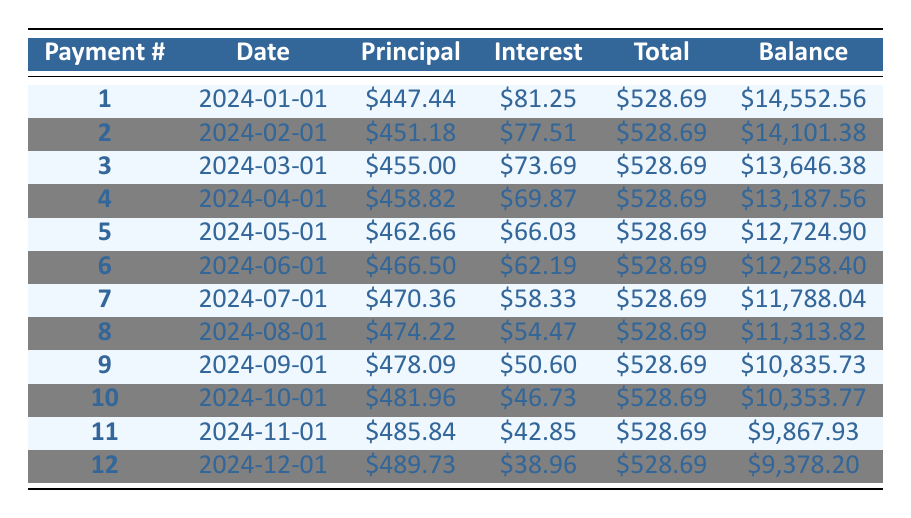What is the total payment amount for each month? The table shows a consistent total payment of \$528.69 for each month, which suggests that the payment schedule is structured with fixed payments.
Answer: 528.69 What is the total amount paid in interest after the first year (12 payments)? To find the total interest paid, sum the interest payments over the first 12 months: (81.25 + 77.51 + 73.69 + 69.87 + 66.03 + 62.19 + 58.33 + 54.47 + 50.60 + 46.73 + 42.85 + 38.96) =  724.26.
Answer: 724.26 Is the principal payment increasing or decreasing over the months? From the table, the principal payment starts at \$447.44 in the first month and increases to \$489.73 by the 12th month. Thus, the principal payment is increasing over time.
Answer: Yes What was the remaining balance after 6 months of payments? The remaining balance after 6 months is listed as \$12,258.40 in the table, corresponding to the 6th payment.
Answer: 12,258.40 What is the difference in interest payment between the first and last month of the first year? The interest payment in the first month is \$81.25, and in the 12th month, it is \$38.96. The difference is \$81.25 - \$38.96 = \$42.29.
Answer: 42.29 What was the total amount paid towards the principal in the first 6 months? To calculate the total principal payments, sum the principal amounts from the 1st to the 6th payment: (447.44 + 451.18 + 455.00 + 458.82 + 462.66 + 466.50) = 2,441.60.
Answer: 2,441.60 Is the monthly principal payment greater than \$400 in the first 6 months? Looking at the principal payments for the first 6 months, all values (447.44, 451.18, 455.00, 458.82, 462.66, and 466.50) are greater than \$400.
Answer: Yes What is the percentage of the total loan amount that remains after the first payment? The total loan amount is \$15,000. The remaining balance after the first payment is \$14,552.56. The percentage remaining is ((14,552.56 / 15,000) * 100) = 97.02%.
Answer: 97.02% 